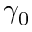Convert formula to latex. <formula><loc_0><loc_0><loc_500><loc_500>\gamma _ { 0 }</formula> 